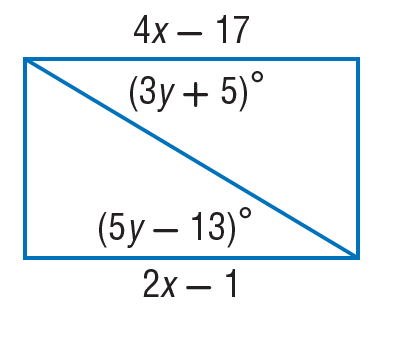Answer the mathemtical geometry problem and directly provide the correct option letter.
Question: Find y so that the quadrilateral is a parallelogram.
Choices: A: 1 B: 9 C: 17 D: 29 B 